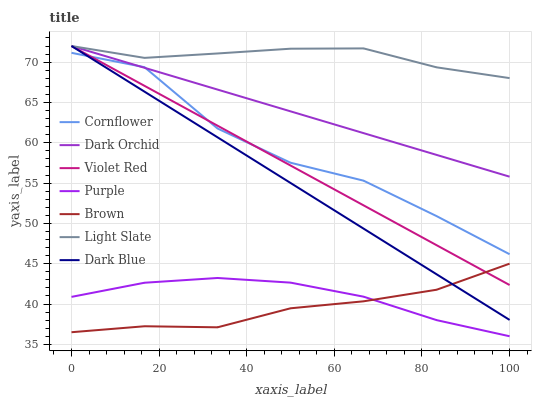Does Brown have the minimum area under the curve?
Answer yes or no. Yes. Does Light Slate have the maximum area under the curve?
Answer yes or no. Yes. Does Violet Red have the minimum area under the curve?
Answer yes or no. No. Does Violet Red have the maximum area under the curve?
Answer yes or no. No. Is Dark Blue the smoothest?
Answer yes or no. Yes. Is Cornflower the roughest?
Answer yes or no. Yes. Is Violet Red the smoothest?
Answer yes or no. No. Is Violet Red the roughest?
Answer yes or no. No. Does Purple have the lowest value?
Answer yes or no. Yes. Does Violet Red have the lowest value?
Answer yes or no. No. Does Dark Blue have the highest value?
Answer yes or no. Yes. Does Brown have the highest value?
Answer yes or no. No. Is Purple less than Dark Blue?
Answer yes or no. Yes. Is Light Slate greater than Purple?
Answer yes or no. Yes. Does Brown intersect Violet Red?
Answer yes or no. Yes. Is Brown less than Violet Red?
Answer yes or no. No. Is Brown greater than Violet Red?
Answer yes or no. No. Does Purple intersect Dark Blue?
Answer yes or no. No. 